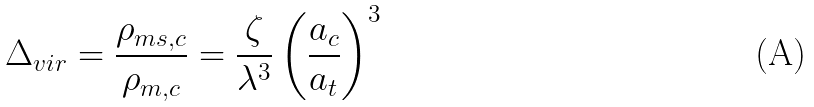<formula> <loc_0><loc_0><loc_500><loc_500>\Delta _ { v i r } = \frac { \rho _ { m s , c } } { \rho _ { m , c } } = \frac { \zeta } { \lambda ^ { 3 } } \left ( \frac { a _ { c } } { a _ { t } } \right ) ^ { 3 }</formula> 